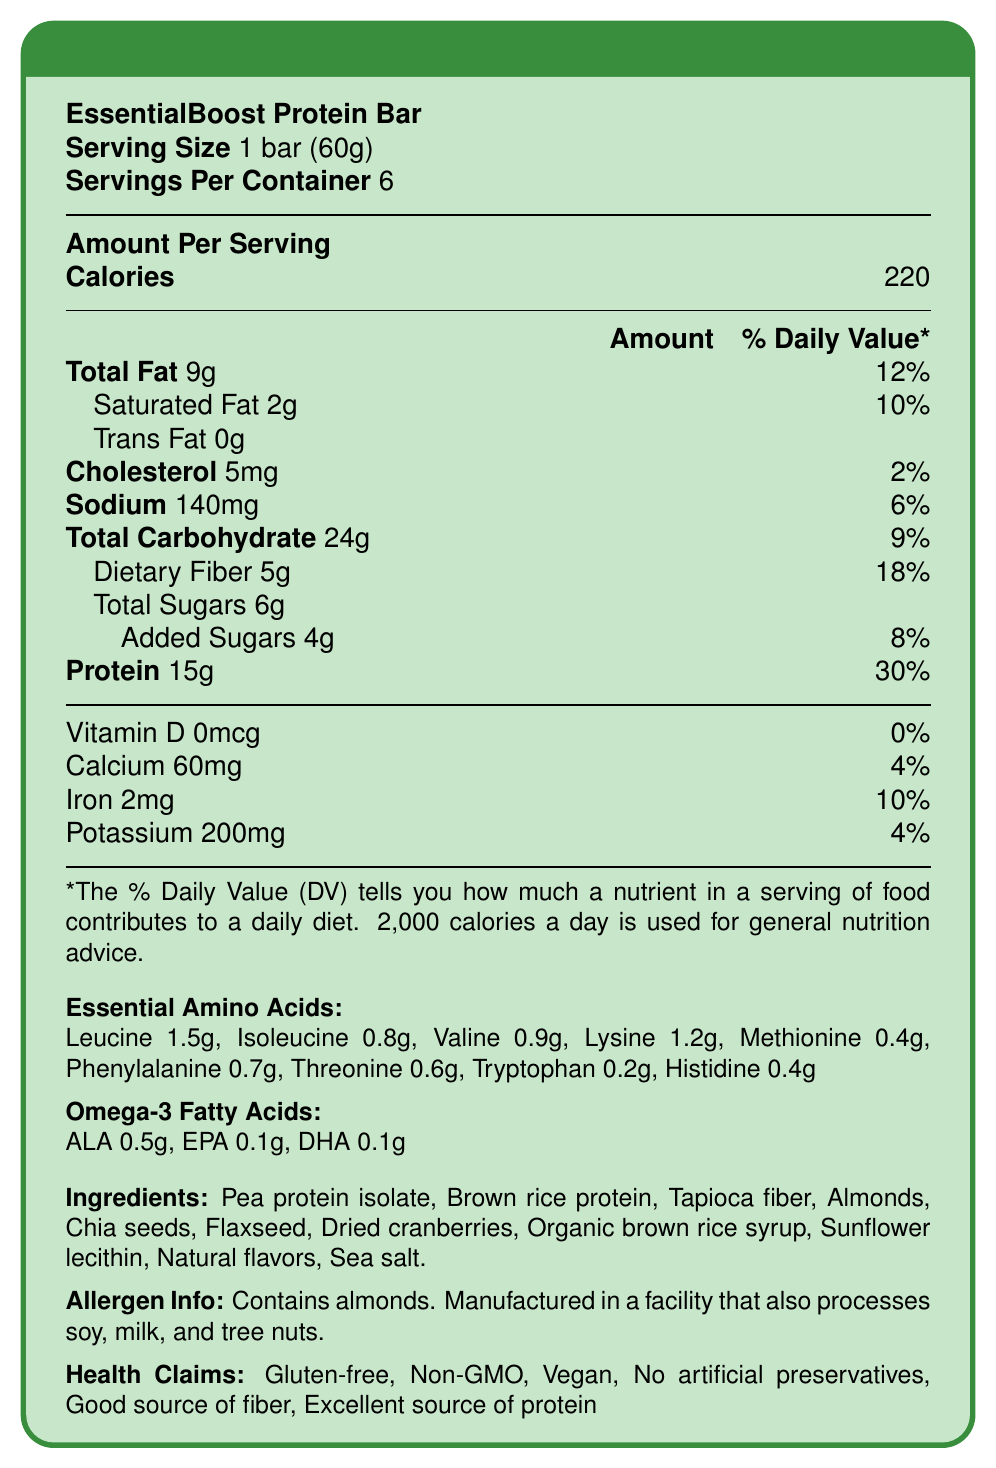what is the serving size of EssentialBoost Protein Bar? The serving size is specified at the beginning of the nutritional information.
Answer: 1 bar (60g) how many calories are in one serving of the protein bar? The number of calories per serving is listed under the "Amount Per Serving" section.
Answer: 220 what is the total fat content per serving? The total fat content is given under the "Total Fat" row in the nutritional table.
Answer: 9g how much dietary fiber does one bar contain? The dietary fiber content is listed under the "Dietary Fiber" row in the nutritional table.
Answer: 5g how much protein does one serving provide? The protein content per serving is mentioned in the nutritional table.
Answer: 15g which of the following amino acids is present in the greatest amount in one bar? A. Lysine B. Valine C. Leucine The essential amino acids section shows leucine at 1.5g, while lysine and valine are 1.2g and 0.9g respectively.
Answer: C how much omega-3 fatty acid ALA is present in the bar? A. 0.1g B. 0.5g C. 1g The omega-3 fatty acids section lists ALA content as 0.5g.
Answer: B does the nutrition facts label indicate the amount of Vitamin D in the product? The amount of Vitamin D is stated as 0mcg.
Answer: Yes is the EssentialBoost Protein Bar suitable for someone with a gluten allergy? The health claims section states "Gluten-free," indicating it is safe for people with gluten allergies.
Answer: Yes summarize the primary nutritional benefits of the EssentialBoost Protein Bar. The document highlights the essential nutritional information and health benefits in a detailed manner.
Answer: The bar provides 220 calories per serving with 9g of total fat, 15g of protein, and 5g of dietary fiber. It's rich in essential amino acids and omega-3 fatty acids and is gluten-free, non-GMO, vegan, and free from artificial preservatives. what is the daily value percentage of sodium in one serving? The sodium daily value percentage is provided in the nutritional table.
Answer: 6% which ingredient contributes to the protein content in the bar? The ingredients list shows that pea protein isolate and brown rice protein are included, likely contributing to the high protein content.
Answer: Pea protein isolate and Brown rice protein how many grams of added sugars are in one bar? A. 2g B. 3g C. 4g D. 6g The nutritional table states that there are 4g of added sugars per bar.
Answer: C what percentage of daily iron value does one serving offer? The iron daily value percentage is given in the nutritional table.
Answer: 10% can it be determined if the EssentialBoost Protein Bar helps with muscle recovery? While the ingredients and some claims suggest it might, the document does not provide specific claims or studies related to muscle recovery.
Answer: Not enough information 